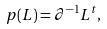Convert formula to latex. <formula><loc_0><loc_0><loc_500><loc_500>p ( L ) = \partial ^ { - 1 } L ^ { t } ,</formula> 